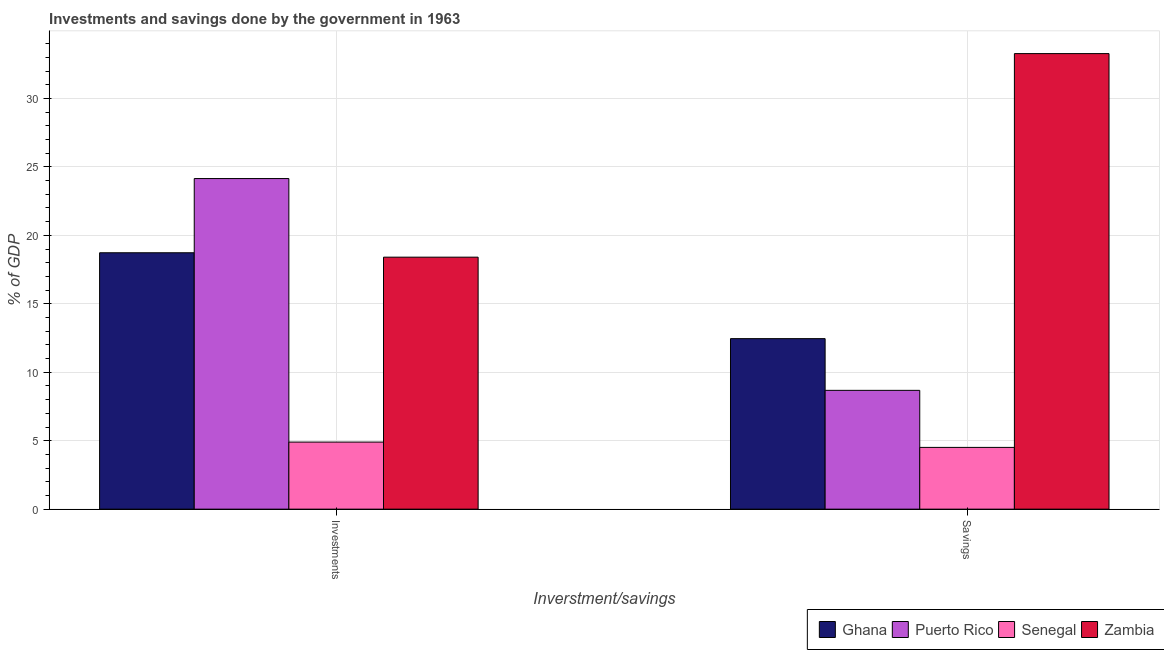How many different coloured bars are there?
Offer a terse response. 4. Are the number of bars per tick equal to the number of legend labels?
Your answer should be compact. Yes. Are the number of bars on each tick of the X-axis equal?
Your answer should be very brief. Yes. How many bars are there on the 2nd tick from the left?
Make the answer very short. 4. What is the label of the 1st group of bars from the left?
Make the answer very short. Investments. What is the savings of government in Senegal?
Make the answer very short. 4.51. Across all countries, what is the maximum savings of government?
Keep it short and to the point. 33.27. Across all countries, what is the minimum investments of government?
Your answer should be compact. 4.9. In which country was the savings of government maximum?
Your response must be concise. Zambia. In which country was the investments of government minimum?
Your answer should be very brief. Senegal. What is the total savings of government in the graph?
Provide a succinct answer. 58.92. What is the difference between the savings of government in Zambia and that in Senegal?
Offer a very short reply. 28.76. What is the difference between the savings of government in Puerto Rico and the investments of government in Zambia?
Give a very brief answer. -9.73. What is the average investments of government per country?
Your answer should be compact. 16.54. What is the difference between the savings of government and investments of government in Zambia?
Offer a very short reply. 14.87. In how many countries, is the investments of government greater than 13 %?
Your response must be concise. 3. What is the ratio of the investments of government in Zambia to that in Ghana?
Provide a short and direct response. 0.98. In how many countries, is the investments of government greater than the average investments of government taken over all countries?
Keep it short and to the point. 3. What does the 3rd bar from the left in Investments represents?
Your answer should be compact. Senegal. Are all the bars in the graph horizontal?
Give a very brief answer. No. What is the difference between two consecutive major ticks on the Y-axis?
Ensure brevity in your answer.  5. Does the graph contain any zero values?
Give a very brief answer. No. Where does the legend appear in the graph?
Ensure brevity in your answer.  Bottom right. How many legend labels are there?
Offer a very short reply. 4. What is the title of the graph?
Your answer should be compact. Investments and savings done by the government in 1963. What is the label or title of the X-axis?
Your response must be concise. Inverstment/savings. What is the label or title of the Y-axis?
Your answer should be very brief. % of GDP. What is the % of GDP of Ghana in Investments?
Offer a terse response. 18.73. What is the % of GDP in Puerto Rico in Investments?
Make the answer very short. 24.15. What is the % of GDP of Senegal in Investments?
Your response must be concise. 4.9. What is the % of GDP of Zambia in Investments?
Your response must be concise. 18.41. What is the % of GDP of Ghana in Savings?
Provide a succinct answer. 12.45. What is the % of GDP of Puerto Rico in Savings?
Your response must be concise. 8.68. What is the % of GDP of Senegal in Savings?
Ensure brevity in your answer.  4.51. What is the % of GDP in Zambia in Savings?
Keep it short and to the point. 33.27. Across all Inverstment/savings, what is the maximum % of GDP of Ghana?
Give a very brief answer. 18.73. Across all Inverstment/savings, what is the maximum % of GDP in Puerto Rico?
Provide a succinct answer. 24.15. Across all Inverstment/savings, what is the maximum % of GDP of Senegal?
Make the answer very short. 4.9. Across all Inverstment/savings, what is the maximum % of GDP in Zambia?
Ensure brevity in your answer.  33.27. Across all Inverstment/savings, what is the minimum % of GDP of Ghana?
Make the answer very short. 12.45. Across all Inverstment/savings, what is the minimum % of GDP of Puerto Rico?
Your answer should be very brief. 8.68. Across all Inverstment/savings, what is the minimum % of GDP of Senegal?
Your answer should be very brief. 4.51. Across all Inverstment/savings, what is the minimum % of GDP in Zambia?
Ensure brevity in your answer.  18.41. What is the total % of GDP of Ghana in the graph?
Keep it short and to the point. 31.18. What is the total % of GDP of Puerto Rico in the graph?
Offer a terse response. 32.82. What is the total % of GDP in Senegal in the graph?
Your response must be concise. 9.41. What is the total % of GDP of Zambia in the graph?
Your response must be concise. 51.68. What is the difference between the % of GDP in Ghana in Investments and that in Savings?
Keep it short and to the point. 6.27. What is the difference between the % of GDP of Puerto Rico in Investments and that in Savings?
Provide a succinct answer. 15.47. What is the difference between the % of GDP of Senegal in Investments and that in Savings?
Ensure brevity in your answer.  0.39. What is the difference between the % of GDP in Zambia in Investments and that in Savings?
Your answer should be compact. -14.87. What is the difference between the % of GDP of Ghana in Investments and the % of GDP of Puerto Rico in Savings?
Keep it short and to the point. 10.05. What is the difference between the % of GDP in Ghana in Investments and the % of GDP in Senegal in Savings?
Your answer should be very brief. 14.22. What is the difference between the % of GDP in Ghana in Investments and the % of GDP in Zambia in Savings?
Provide a short and direct response. -14.55. What is the difference between the % of GDP of Puerto Rico in Investments and the % of GDP of Senegal in Savings?
Ensure brevity in your answer.  19.64. What is the difference between the % of GDP of Puerto Rico in Investments and the % of GDP of Zambia in Savings?
Your response must be concise. -9.13. What is the difference between the % of GDP of Senegal in Investments and the % of GDP of Zambia in Savings?
Your answer should be compact. -28.38. What is the average % of GDP in Ghana per Inverstment/savings?
Give a very brief answer. 15.59. What is the average % of GDP in Puerto Rico per Inverstment/savings?
Provide a short and direct response. 16.41. What is the average % of GDP in Senegal per Inverstment/savings?
Your answer should be very brief. 4.7. What is the average % of GDP of Zambia per Inverstment/savings?
Provide a short and direct response. 25.84. What is the difference between the % of GDP of Ghana and % of GDP of Puerto Rico in Investments?
Provide a succinct answer. -5.42. What is the difference between the % of GDP in Ghana and % of GDP in Senegal in Investments?
Provide a short and direct response. 13.83. What is the difference between the % of GDP in Ghana and % of GDP in Zambia in Investments?
Ensure brevity in your answer.  0.32. What is the difference between the % of GDP of Puerto Rico and % of GDP of Senegal in Investments?
Provide a short and direct response. 19.25. What is the difference between the % of GDP of Puerto Rico and % of GDP of Zambia in Investments?
Your response must be concise. 5.74. What is the difference between the % of GDP in Senegal and % of GDP in Zambia in Investments?
Offer a very short reply. -13.51. What is the difference between the % of GDP of Ghana and % of GDP of Puerto Rico in Savings?
Provide a short and direct response. 3.78. What is the difference between the % of GDP of Ghana and % of GDP of Senegal in Savings?
Provide a succinct answer. 7.94. What is the difference between the % of GDP in Ghana and % of GDP in Zambia in Savings?
Provide a short and direct response. -20.82. What is the difference between the % of GDP of Puerto Rico and % of GDP of Senegal in Savings?
Ensure brevity in your answer.  4.17. What is the difference between the % of GDP in Puerto Rico and % of GDP in Zambia in Savings?
Your answer should be very brief. -24.6. What is the difference between the % of GDP in Senegal and % of GDP in Zambia in Savings?
Offer a very short reply. -28.76. What is the ratio of the % of GDP in Ghana in Investments to that in Savings?
Provide a succinct answer. 1.5. What is the ratio of the % of GDP in Puerto Rico in Investments to that in Savings?
Your response must be concise. 2.78. What is the ratio of the % of GDP of Senegal in Investments to that in Savings?
Ensure brevity in your answer.  1.09. What is the ratio of the % of GDP of Zambia in Investments to that in Savings?
Offer a very short reply. 0.55. What is the difference between the highest and the second highest % of GDP in Ghana?
Keep it short and to the point. 6.27. What is the difference between the highest and the second highest % of GDP in Puerto Rico?
Keep it short and to the point. 15.47. What is the difference between the highest and the second highest % of GDP in Senegal?
Provide a short and direct response. 0.39. What is the difference between the highest and the second highest % of GDP in Zambia?
Your answer should be compact. 14.87. What is the difference between the highest and the lowest % of GDP in Ghana?
Give a very brief answer. 6.27. What is the difference between the highest and the lowest % of GDP in Puerto Rico?
Provide a succinct answer. 15.47. What is the difference between the highest and the lowest % of GDP in Senegal?
Keep it short and to the point. 0.39. What is the difference between the highest and the lowest % of GDP of Zambia?
Make the answer very short. 14.87. 